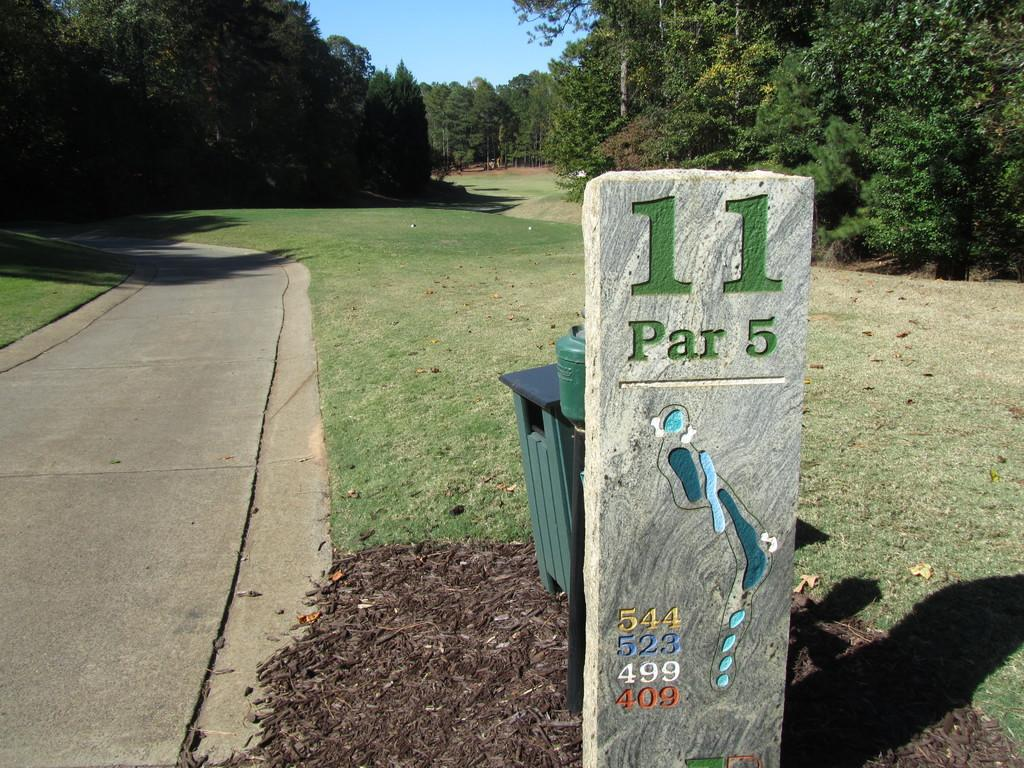Provide a one-sentence caption for the provided image. 11 is a Par 5 marks this golf hole according to the sign. 